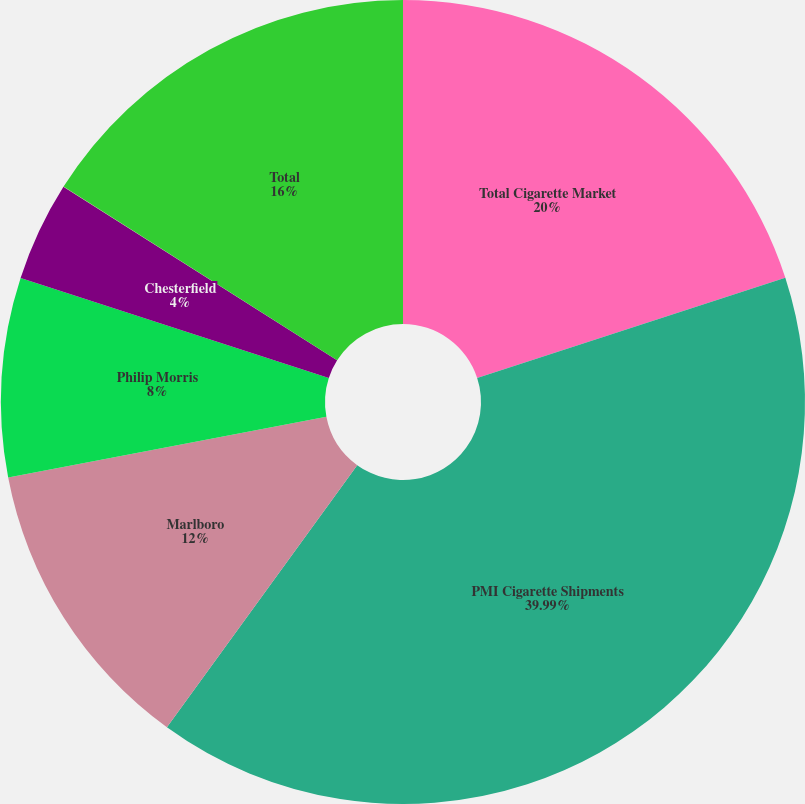Convert chart to OTSL. <chart><loc_0><loc_0><loc_500><loc_500><pie_chart><fcel>Total Cigarette Market<fcel>PMI Cigarette Shipments<fcel>Marlboro<fcel>Philip Morris<fcel>Chesterfield<fcel>Others<fcel>Total<nl><fcel>20.0%<fcel>39.99%<fcel>12.0%<fcel>8.0%<fcel>4.0%<fcel>0.01%<fcel>16.0%<nl></chart> 